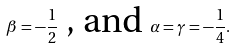Convert formula to latex. <formula><loc_0><loc_0><loc_500><loc_500>\beta = - \frac { 1 } { 2 } \text { , and } \alpha = \gamma = - \frac { 1 } { 4 } .</formula> 